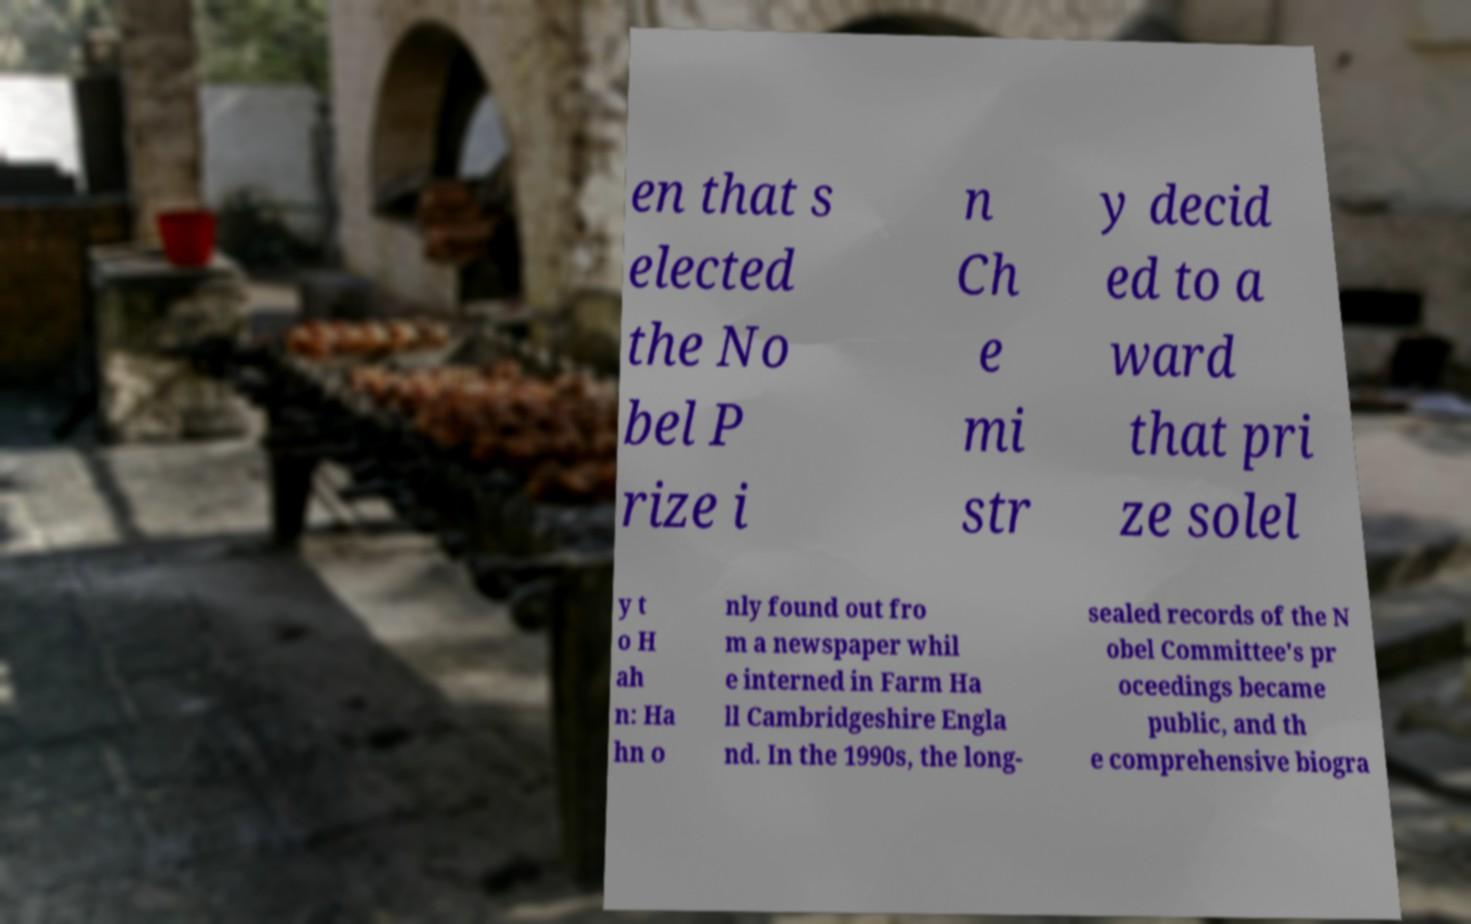Please read and relay the text visible in this image. What does it say? en that s elected the No bel P rize i n Ch e mi str y decid ed to a ward that pri ze solel y t o H ah n: Ha hn o nly found out fro m a newspaper whil e interned in Farm Ha ll Cambridgeshire Engla nd. In the 1990s, the long- sealed records of the N obel Committee's pr oceedings became public, and th e comprehensive biogra 